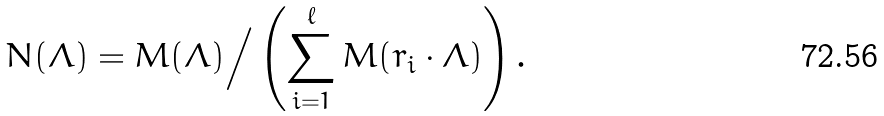Convert formula to latex. <formula><loc_0><loc_0><loc_500><loc_500>N ( \Lambda ) = M ( \Lambda ) \Big / \left ( \sum _ { i = 1 } ^ { \ell } M ( r _ { i } \cdot \Lambda ) \right ) .</formula> 